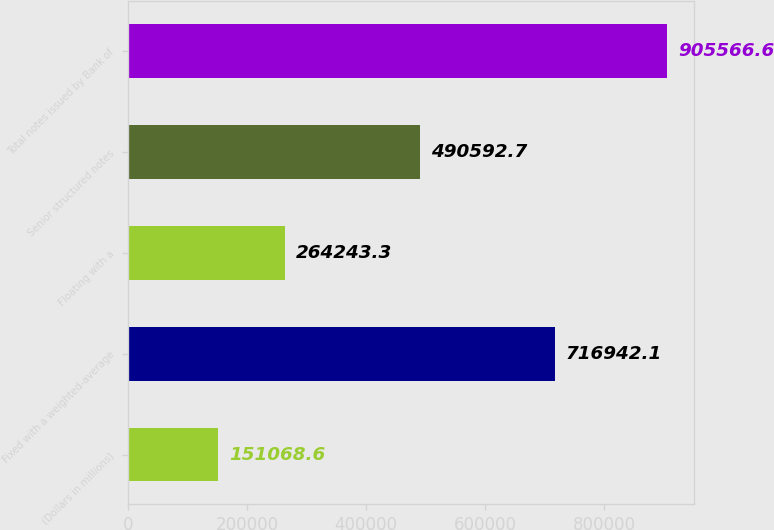<chart> <loc_0><loc_0><loc_500><loc_500><bar_chart><fcel>(Dollars in millions)<fcel>Fixed with a weighted-average<fcel>Floating with a<fcel>Senior structured notes<fcel>Total notes issued by Bank of<nl><fcel>151069<fcel>716942<fcel>264243<fcel>490593<fcel>905567<nl></chart> 